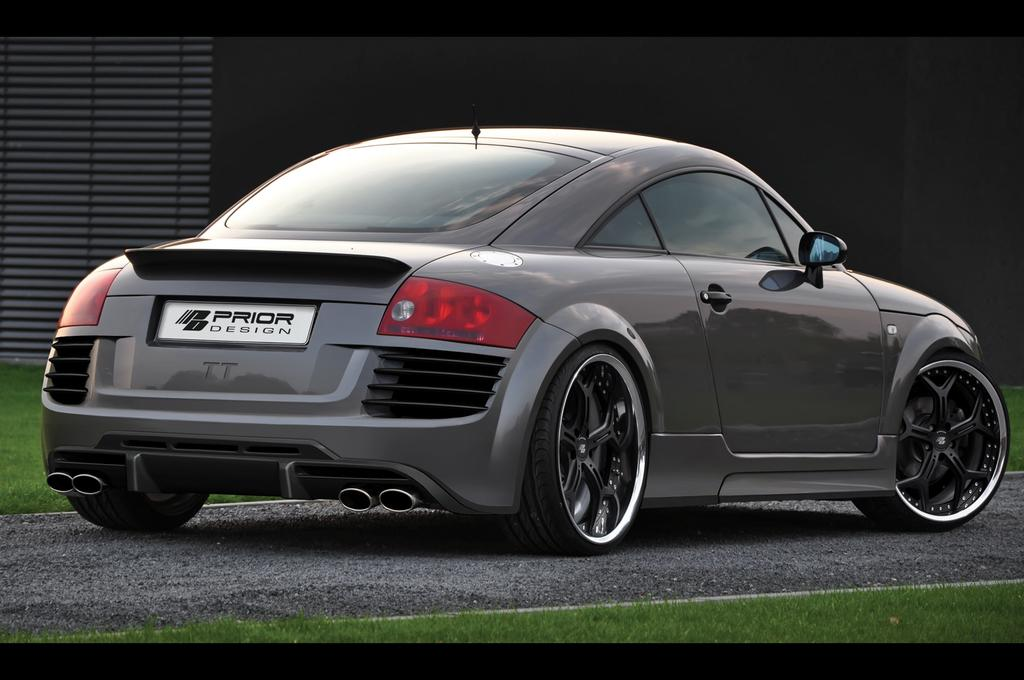What type of terrain is visible at the bottom of the image? There is a grassy land at the bottom of the image. What can be seen in the middle of the image? There is a car present in the middle of the image. What is visible in the background of the image? There is a wall in the background of the image. What type of marble is visible on the grassy land in the image? There is no marble present in the image; it features a grassy land and a car. Can you see a duck walking on the grassy land in the image? There is no duck present in the image; it only features a grassy land and a car. 